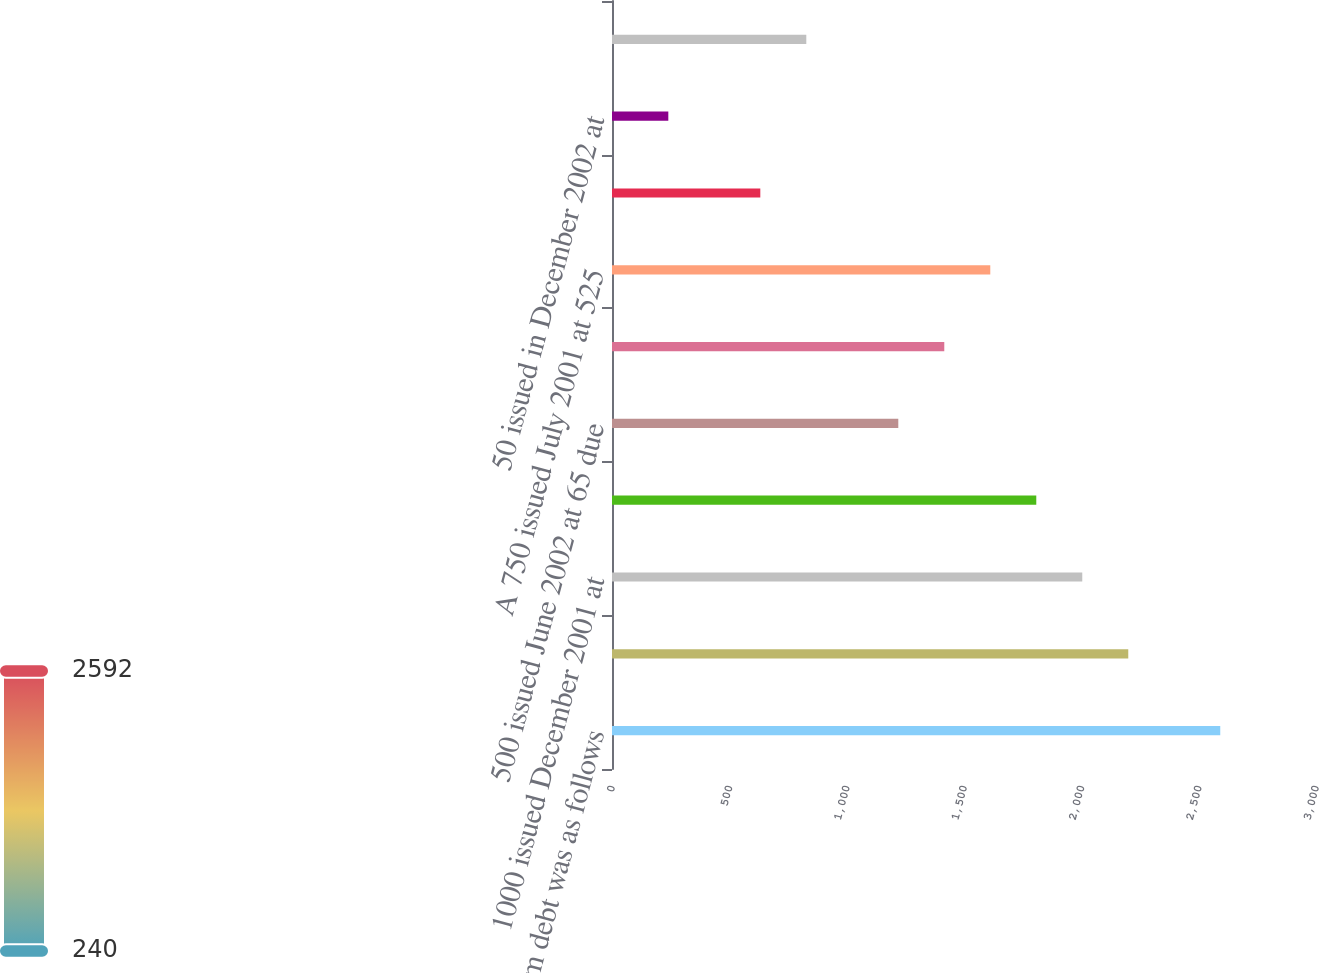Convert chart. <chart><loc_0><loc_0><loc_500><loc_500><bar_chart><fcel>Long-term debt was as follows<fcel>1500 issued June 2000 at 715<fcel>1000 issued December 2001 at<fcel>1000 issued June 2002 at 55<fcel>500 issued June 2002 at 65 due<fcel>500 issued March 2003 at 3625<fcel>A 750 issued July 2001 at 525<fcel>200 issued December 2002 at<fcel>50 issued in December 2002 at<fcel>300 Medium-Term Notes assumed<nl><fcel>2592<fcel>2200<fcel>2004<fcel>1808<fcel>1220<fcel>1416<fcel>1612<fcel>632<fcel>240<fcel>828<nl></chart> 